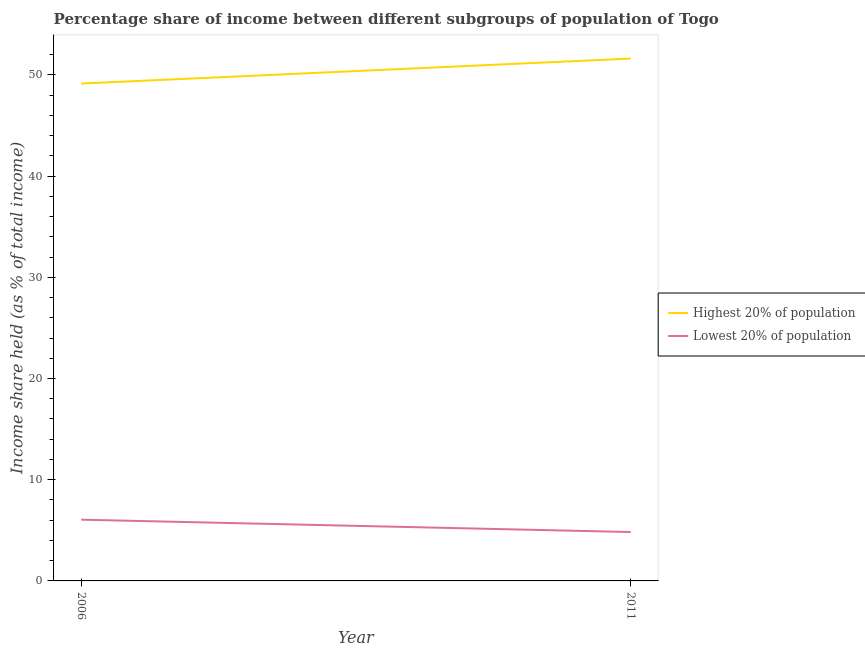How many different coloured lines are there?
Ensure brevity in your answer.  2. What is the income share held by highest 20% of the population in 2011?
Your answer should be very brief. 51.61. Across all years, what is the maximum income share held by highest 20% of the population?
Give a very brief answer. 51.61. Across all years, what is the minimum income share held by lowest 20% of the population?
Keep it short and to the point. 4.83. In which year was the income share held by highest 20% of the population maximum?
Keep it short and to the point. 2011. What is the total income share held by highest 20% of the population in the graph?
Your response must be concise. 100.75. What is the difference between the income share held by lowest 20% of the population in 2006 and that in 2011?
Keep it short and to the point. 1.22. What is the difference between the income share held by lowest 20% of the population in 2011 and the income share held by highest 20% of the population in 2006?
Your response must be concise. -44.31. What is the average income share held by highest 20% of the population per year?
Offer a very short reply. 50.38. In the year 2006, what is the difference between the income share held by highest 20% of the population and income share held by lowest 20% of the population?
Offer a very short reply. 43.09. In how many years, is the income share held by lowest 20% of the population greater than 28 %?
Ensure brevity in your answer.  0. What is the ratio of the income share held by highest 20% of the population in 2006 to that in 2011?
Your response must be concise. 0.95. In how many years, is the income share held by highest 20% of the population greater than the average income share held by highest 20% of the population taken over all years?
Provide a succinct answer. 1. Does the income share held by lowest 20% of the population monotonically increase over the years?
Offer a terse response. No. What is the difference between two consecutive major ticks on the Y-axis?
Offer a very short reply. 10. Are the values on the major ticks of Y-axis written in scientific E-notation?
Provide a short and direct response. No. Does the graph contain any zero values?
Give a very brief answer. No. Does the graph contain grids?
Your answer should be very brief. No. Where does the legend appear in the graph?
Give a very brief answer. Center right. How many legend labels are there?
Offer a terse response. 2. What is the title of the graph?
Your answer should be very brief. Percentage share of income between different subgroups of population of Togo. Does "Export" appear as one of the legend labels in the graph?
Your answer should be compact. No. What is the label or title of the X-axis?
Your response must be concise. Year. What is the label or title of the Y-axis?
Your answer should be very brief. Income share held (as % of total income). What is the Income share held (as % of total income) in Highest 20% of population in 2006?
Offer a very short reply. 49.14. What is the Income share held (as % of total income) of Lowest 20% of population in 2006?
Give a very brief answer. 6.05. What is the Income share held (as % of total income) of Highest 20% of population in 2011?
Ensure brevity in your answer.  51.61. What is the Income share held (as % of total income) in Lowest 20% of population in 2011?
Offer a very short reply. 4.83. Across all years, what is the maximum Income share held (as % of total income) of Highest 20% of population?
Give a very brief answer. 51.61. Across all years, what is the maximum Income share held (as % of total income) of Lowest 20% of population?
Your response must be concise. 6.05. Across all years, what is the minimum Income share held (as % of total income) of Highest 20% of population?
Your answer should be compact. 49.14. Across all years, what is the minimum Income share held (as % of total income) of Lowest 20% of population?
Provide a succinct answer. 4.83. What is the total Income share held (as % of total income) in Highest 20% of population in the graph?
Your response must be concise. 100.75. What is the total Income share held (as % of total income) in Lowest 20% of population in the graph?
Offer a terse response. 10.88. What is the difference between the Income share held (as % of total income) in Highest 20% of population in 2006 and that in 2011?
Provide a short and direct response. -2.47. What is the difference between the Income share held (as % of total income) of Lowest 20% of population in 2006 and that in 2011?
Keep it short and to the point. 1.22. What is the difference between the Income share held (as % of total income) of Highest 20% of population in 2006 and the Income share held (as % of total income) of Lowest 20% of population in 2011?
Offer a very short reply. 44.31. What is the average Income share held (as % of total income) in Highest 20% of population per year?
Your answer should be very brief. 50.38. What is the average Income share held (as % of total income) of Lowest 20% of population per year?
Your answer should be very brief. 5.44. In the year 2006, what is the difference between the Income share held (as % of total income) in Highest 20% of population and Income share held (as % of total income) in Lowest 20% of population?
Keep it short and to the point. 43.09. In the year 2011, what is the difference between the Income share held (as % of total income) of Highest 20% of population and Income share held (as % of total income) of Lowest 20% of population?
Make the answer very short. 46.78. What is the ratio of the Income share held (as % of total income) of Highest 20% of population in 2006 to that in 2011?
Provide a succinct answer. 0.95. What is the ratio of the Income share held (as % of total income) of Lowest 20% of population in 2006 to that in 2011?
Your answer should be very brief. 1.25. What is the difference between the highest and the second highest Income share held (as % of total income) of Highest 20% of population?
Provide a succinct answer. 2.47. What is the difference between the highest and the second highest Income share held (as % of total income) of Lowest 20% of population?
Give a very brief answer. 1.22. What is the difference between the highest and the lowest Income share held (as % of total income) in Highest 20% of population?
Keep it short and to the point. 2.47. What is the difference between the highest and the lowest Income share held (as % of total income) of Lowest 20% of population?
Make the answer very short. 1.22. 